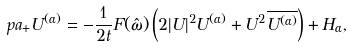<formula> <loc_0><loc_0><loc_500><loc_500>\ p a _ { + } U ^ { ( \alpha ) } = - \frac { 1 } { 2 t } F ( \hat { \omega } ) \left ( 2 | U | ^ { 2 } U ^ { ( \alpha ) } + U ^ { 2 } \overline { U ^ { ( \alpha ) } } \right ) + H _ { \alpha } ,</formula> 